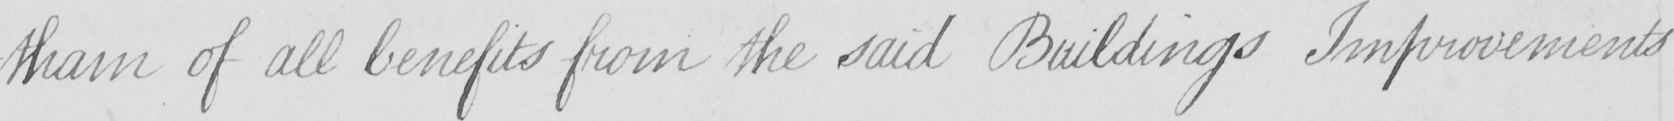Can you read and transcribe this handwriting? -tham of all benefits from the said Buildings Improvements 